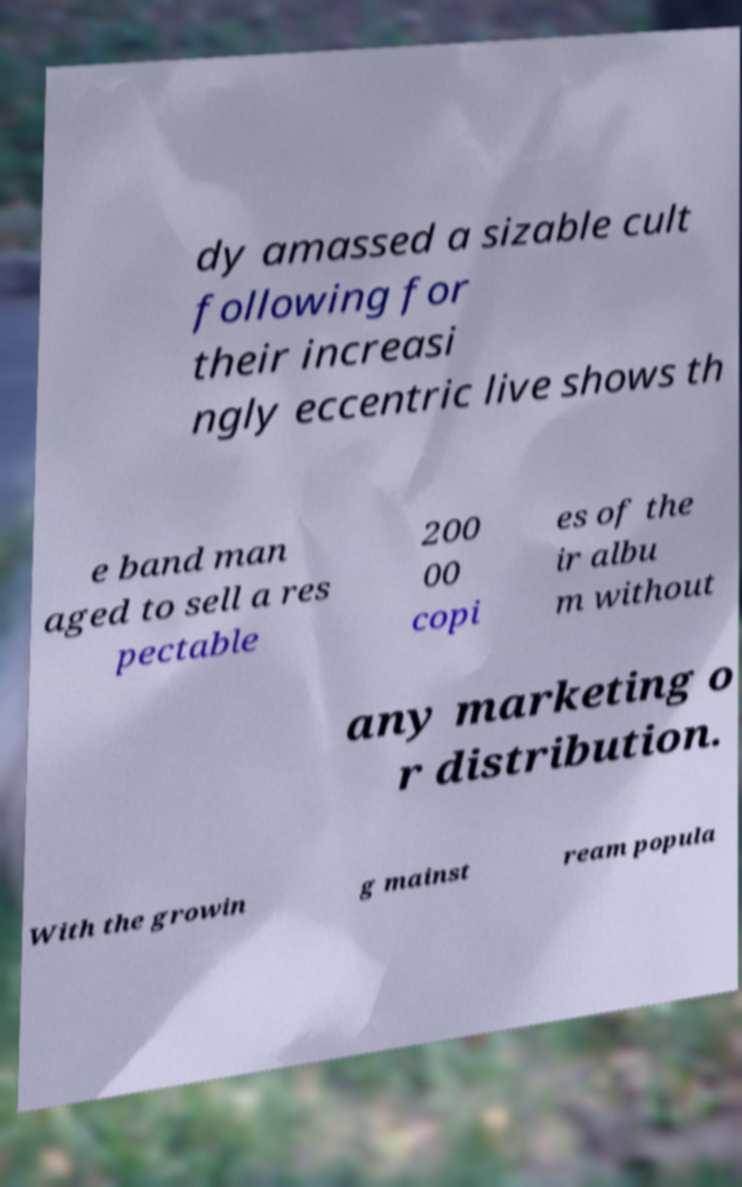Please identify and transcribe the text found in this image. dy amassed a sizable cult following for their increasi ngly eccentric live shows th e band man aged to sell a res pectable 200 00 copi es of the ir albu m without any marketing o r distribution. With the growin g mainst ream popula 